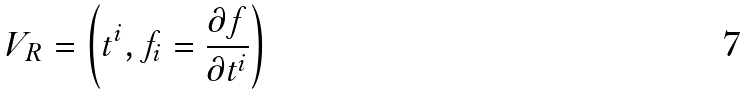Convert formula to latex. <formula><loc_0><loc_0><loc_500><loc_500>V _ { R } = \left ( t ^ { i } , f _ { i } = \frac { \partial f } { \partial t ^ { i } } \right )</formula> 